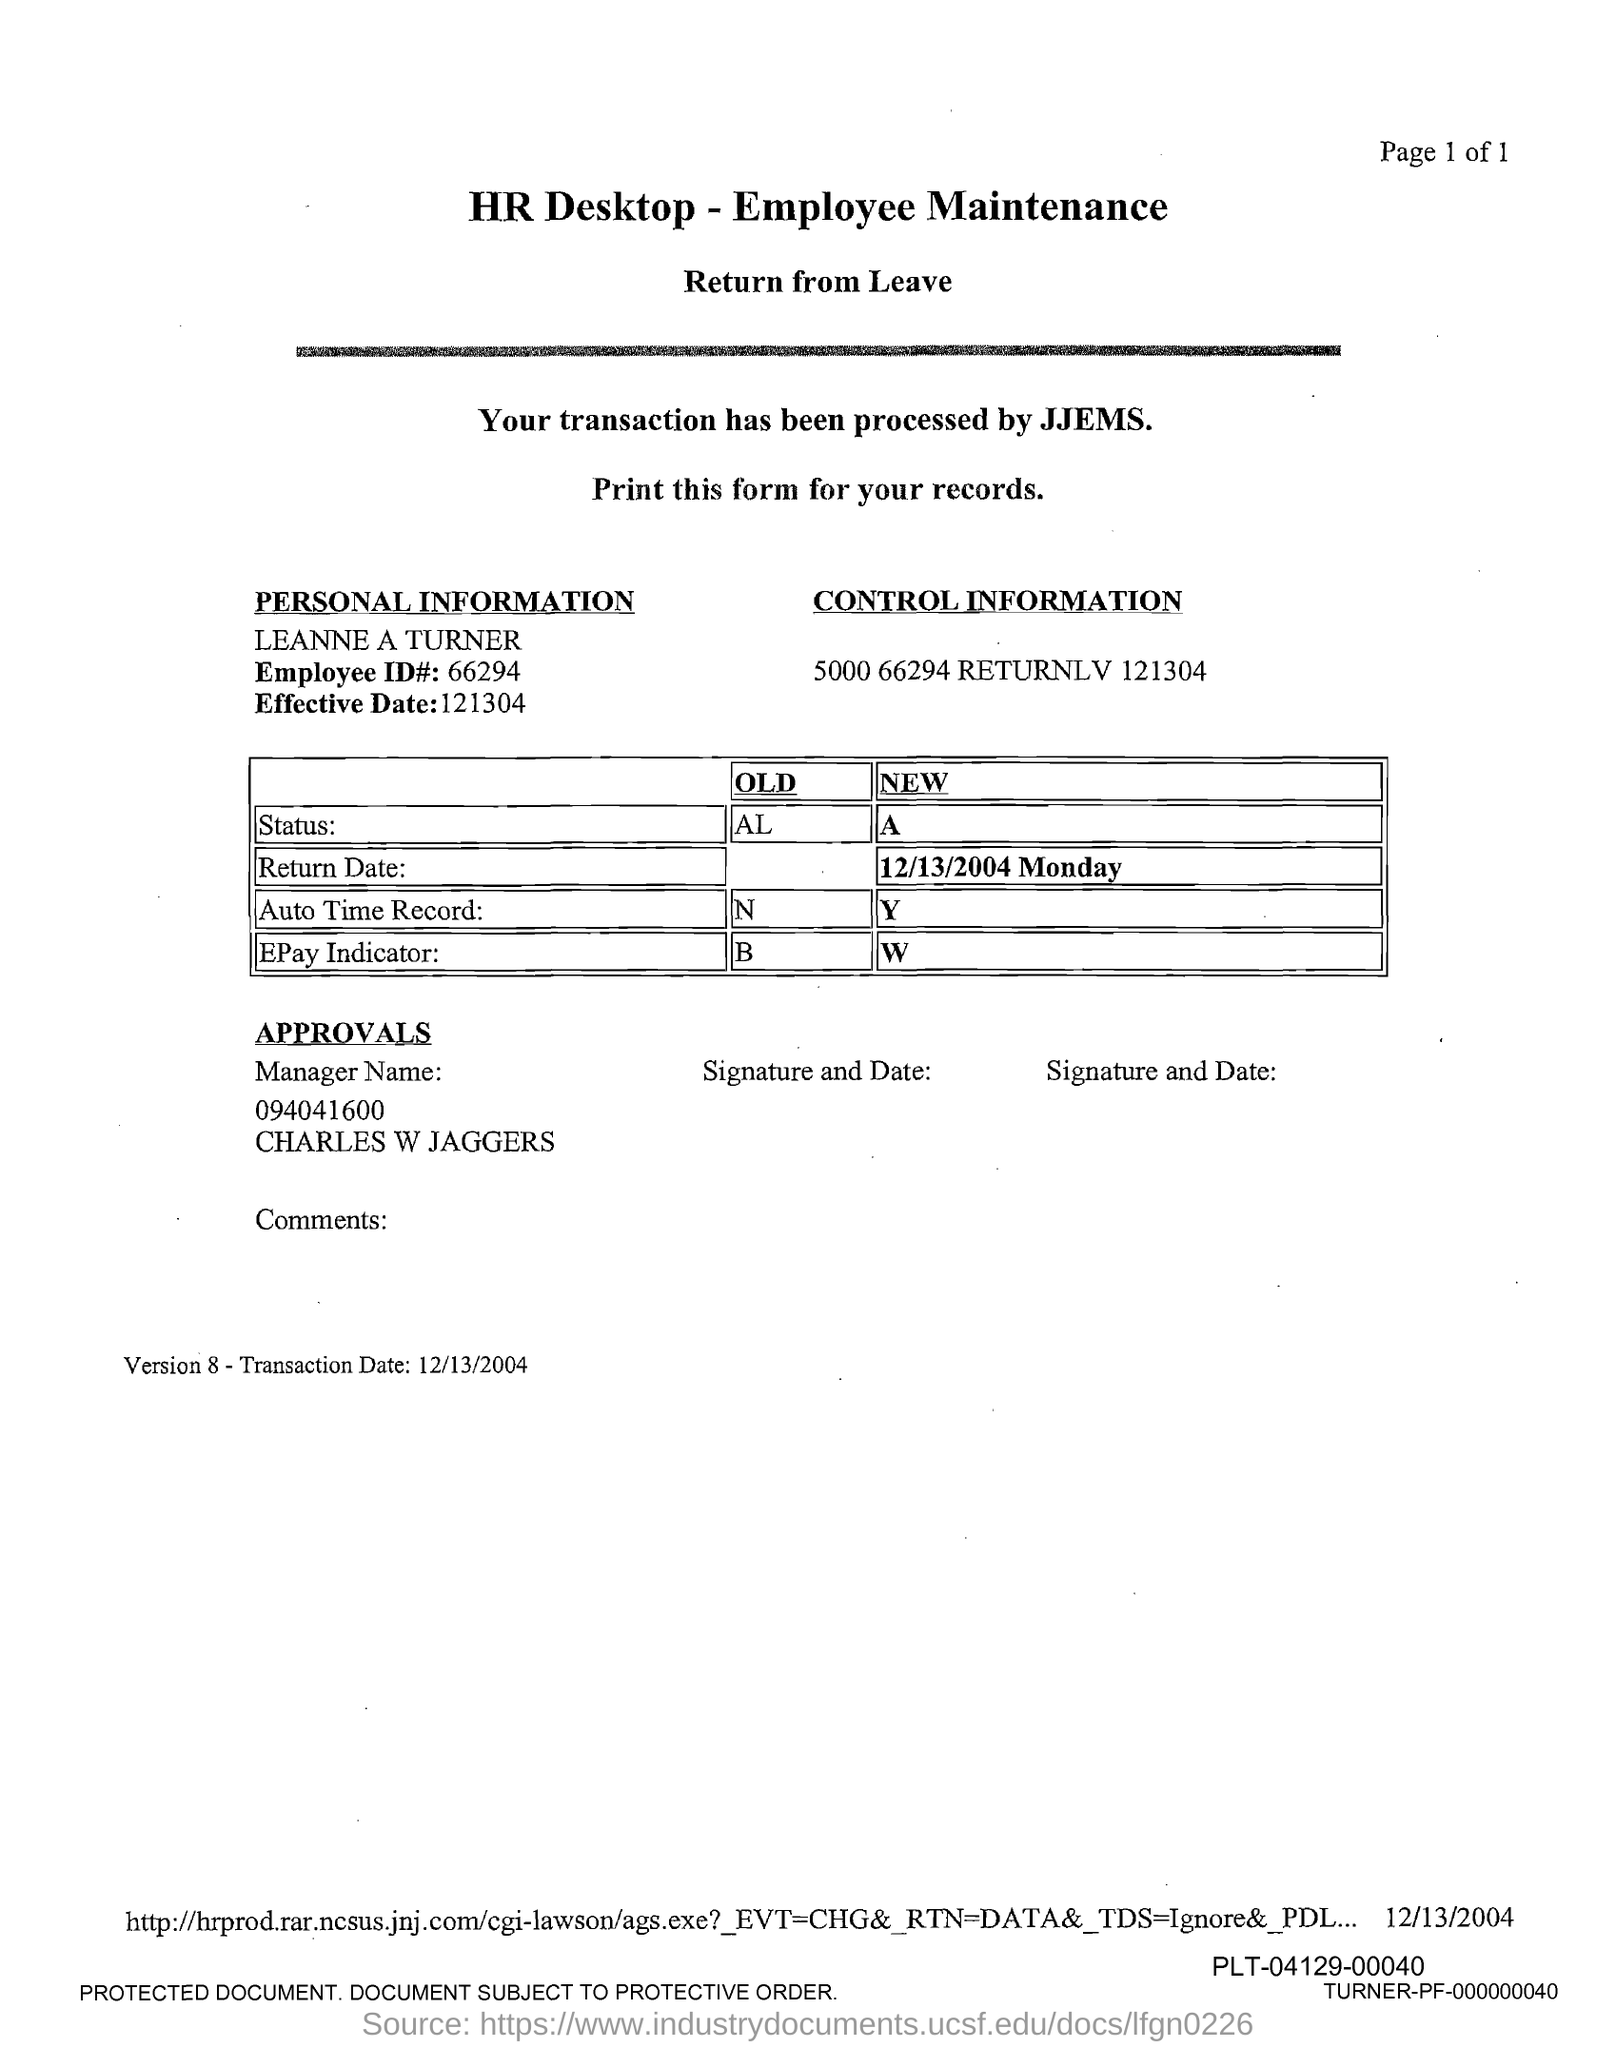What is the Title of the document?
Offer a terse response. HR Desktop - Employee Maintenance. Who is processing the Transaction?
Offer a terse response. JJEMS. What is the Old status?
Offer a very short reply. AL. What is the New Status?
Your response must be concise. A. What is the old Auto Time record?
Your response must be concise. N. What is the New Auto time record?
Provide a succinct answer. Y. What is the New Epay indicator?
Ensure brevity in your answer.  W. What is the Old Epay indicator?
Your response must be concise. B. What is the transaction date?
Offer a terse response. 12/13/2004. 